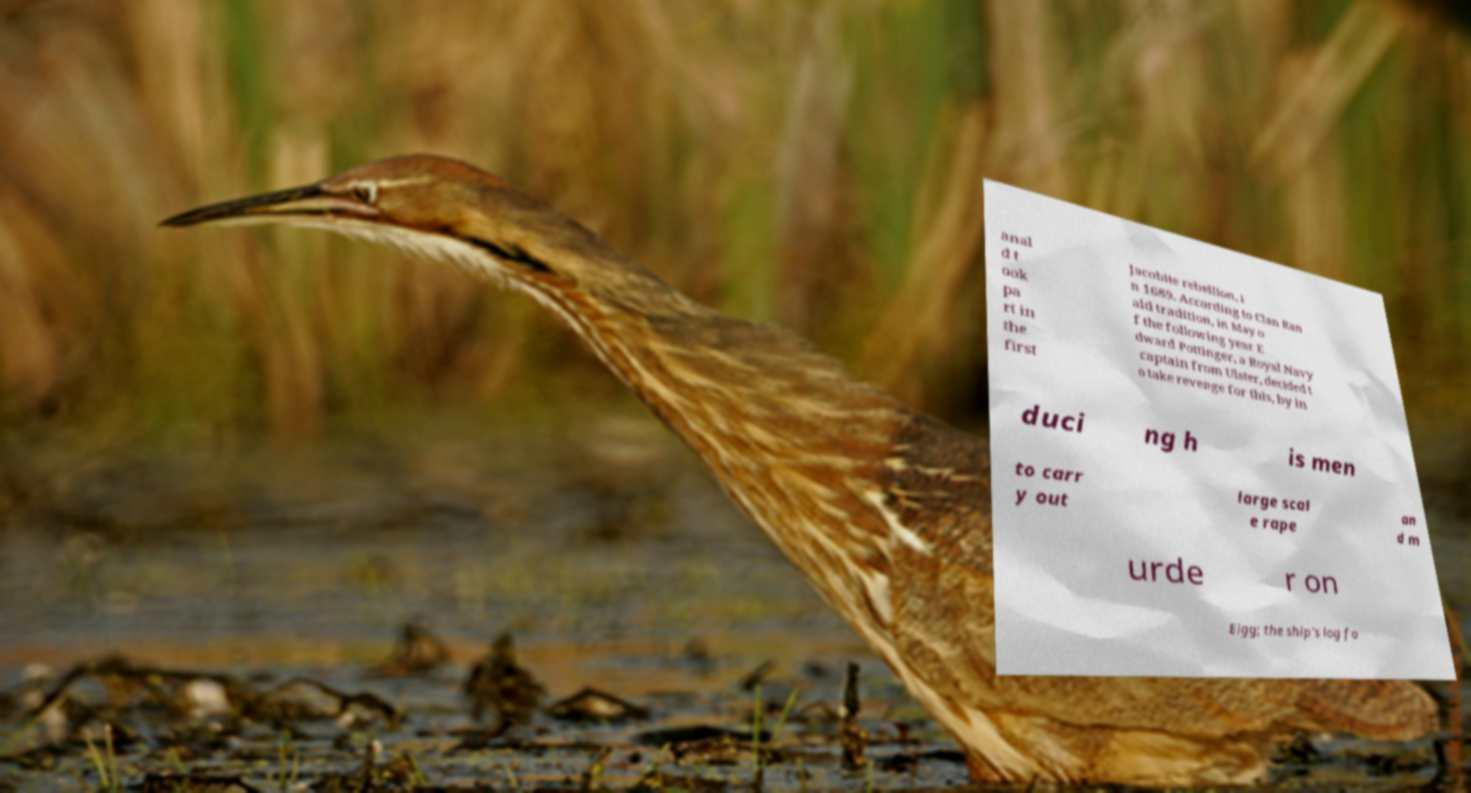Could you assist in decoding the text presented in this image and type it out clearly? anal d t ook pa rt in the first Jacobite rebellion, i n 1689. According to Clan Ran ald tradition, in May o f the following year E dward Pottinger, a Royal Navy captain from Ulster, decided t o take revenge for this, by in duci ng h is men to carr y out large scal e rape an d m urde r on Eigg; the ship's log fo 